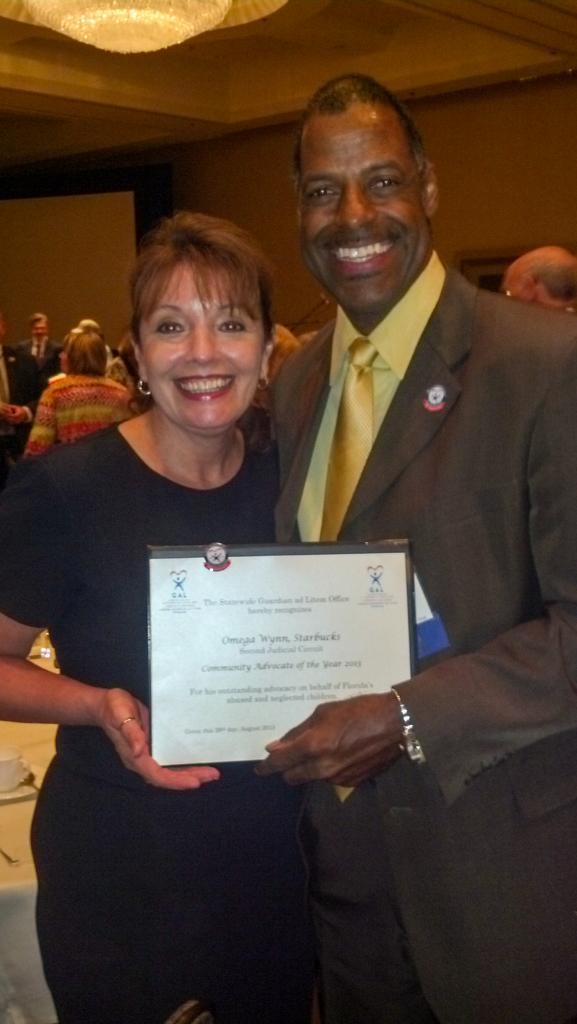Can you describe this image briefly? In this picture we can see a man and a woman standing and holding a certificate, in the background there are some people here, we can see a table on the left side, we can see a chandelier at the top of the picture. 